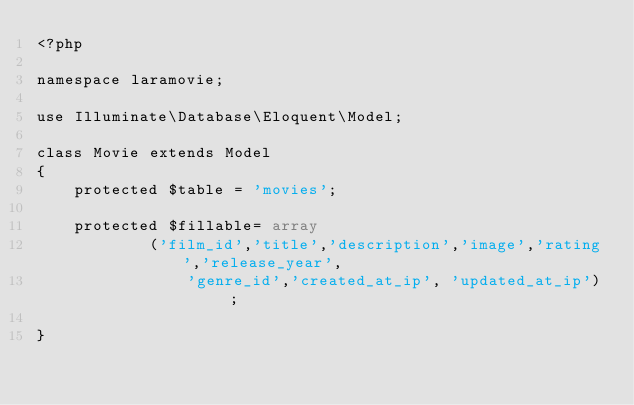Convert code to text. <code><loc_0><loc_0><loc_500><loc_500><_PHP_><?php

namespace laramovie;

use Illuminate\Database\Eloquent\Model;

class Movie extends Model
{
	protected $table = 'movies';
	
	protected $fillable= array
			('film_id','title','description','image','rating','release_year',
				'genre_id','created_at_ip', 'updated_at_ip') ;
    
}
</code> 